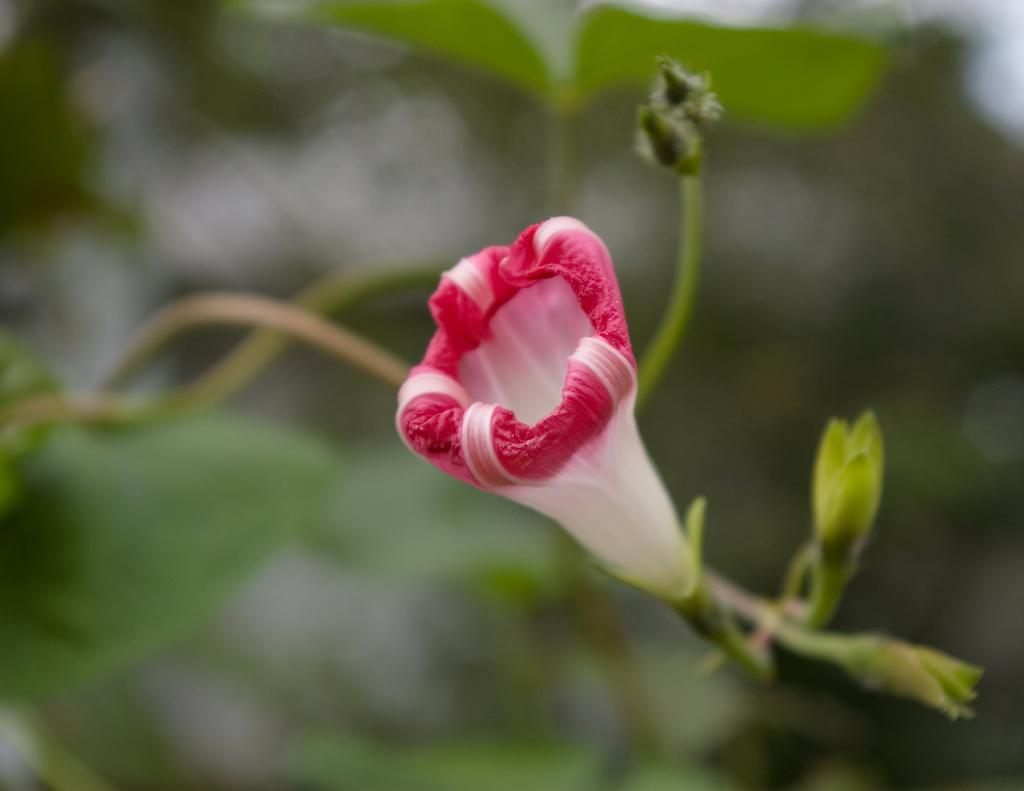What is the main subject of the image? There is a flower in the center of the image. Can you describe the colors of the flower? The flower has red and white colors. What type of property is for sale in the image? There is no property for sale in the image; it features a flower with red and white colors. Can you tell me how many engines are visible in the image? There are no engines present in the image; it features a flower with red and white colors. 